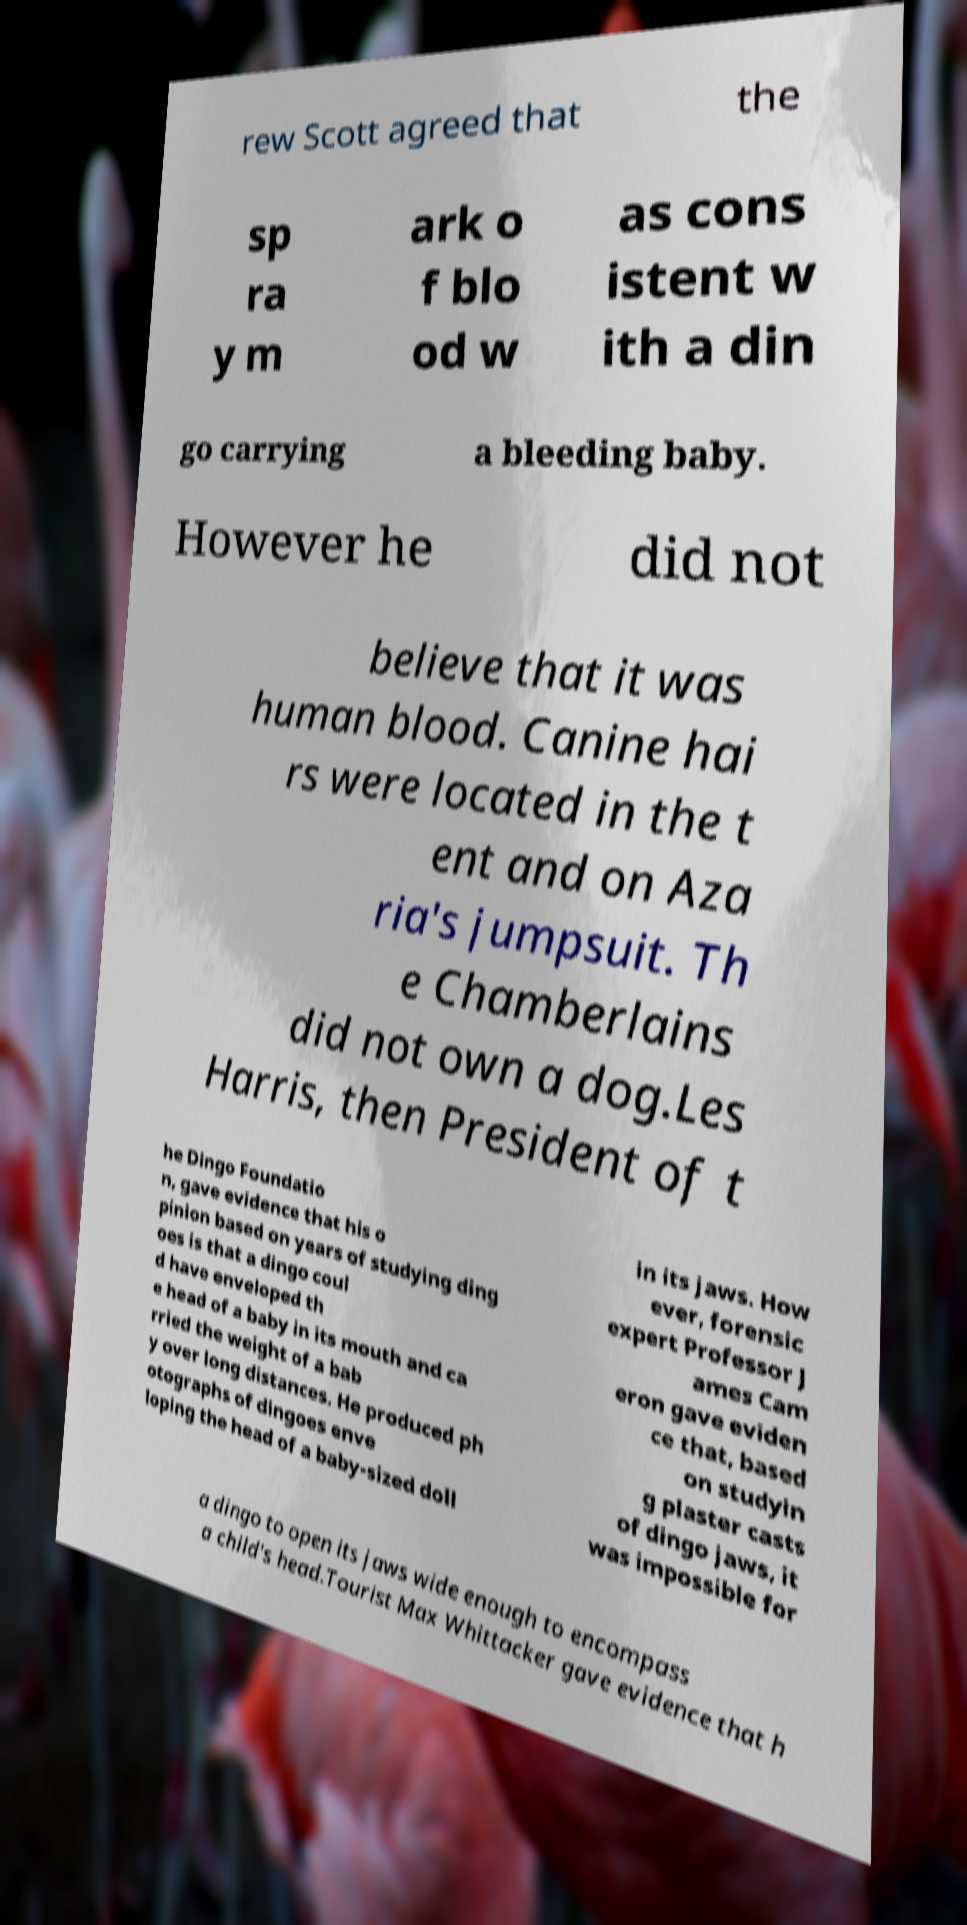Could you extract and type out the text from this image? rew Scott agreed that the sp ra y m ark o f blo od w as cons istent w ith a din go carrying a bleeding baby. However he did not believe that it was human blood. Canine hai rs were located in the t ent and on Aza ria's jumpsuit. Th e Chamberlains did not own a dog.Les Harris, then President of t he Dingo Foundatio n, gave evidence that his o pinion based on years of studying ding oes is that a dingo coul d have enveloped th e head of a baby in its mouth and ca rried the weight of a bab y over long distances. He produced ph otographs of dingoes enve loping the head of a baby-sized doll in its jaws. How ever, forensic expert Professor J ames Cam eron gave eviden ce that, based on studyin g plaster casts of dingo jaws, it was impossible for a dingo to open its jaws wide enough to encompass a child's head.Tourist Max Whittacker gave evidence that h 